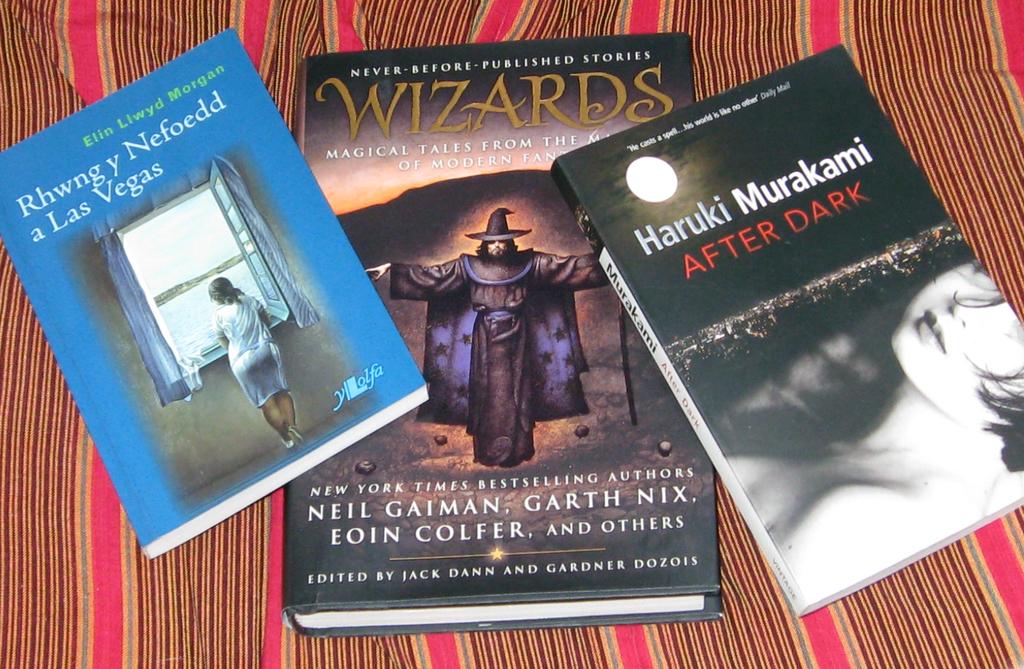What book did elin morgan write?
Your answer should be compact. Rhwng y nefoedd a las vegas. What is the title of the book on the right?
Ensure brevity in your answer.  After dark. 